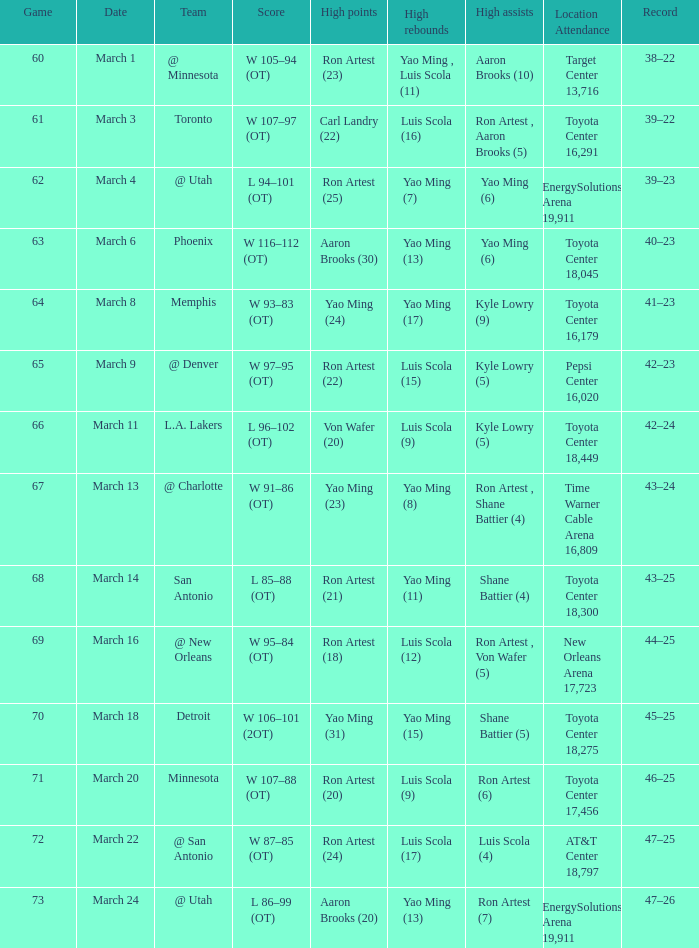Who obtained the most points in game 72? Ron Artest (24). 